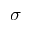Convert formula to latex. <formula><loc_0><loc_0><loc_500><loc_500>\sigma</formula> 